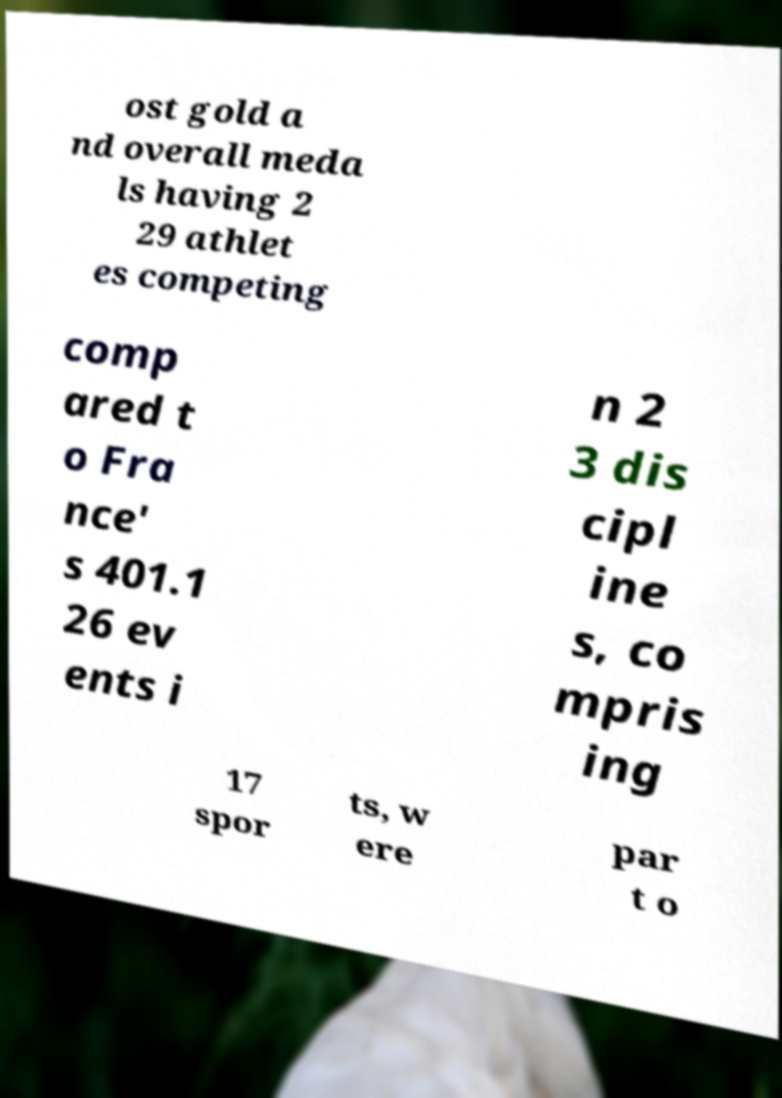For documentation purposes, I need the text within this image transcribed. Could you provide that? ost gold a nd overall meda ls having 2 29 athlet es competing comp ared t o Fra nce' s 401.1 26 ev ents i n 2 3 dis cipl ine s, co mpris ing 17 spor ts, w ere par t o 